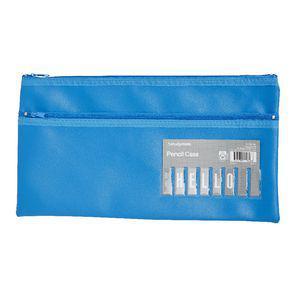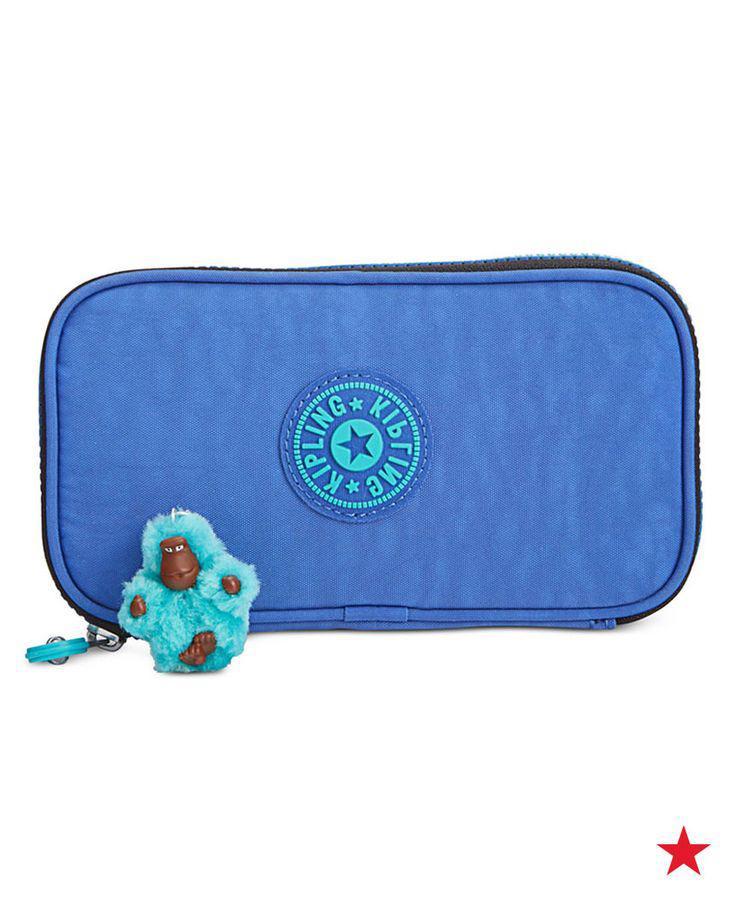The first image is the image on the left, the second image is the image on the right. For the images displayed, is the sentence "There is a thick pencil case and a thin one, both closed." factually correct? Answer yes or no. Yes. The first image is the image on the left, the second image is the image on the right. For the images shown, is this caption "An image shows a closed, flat case with red and blue elements and multiple zippers across the front." true? Answer yes or no. No. 